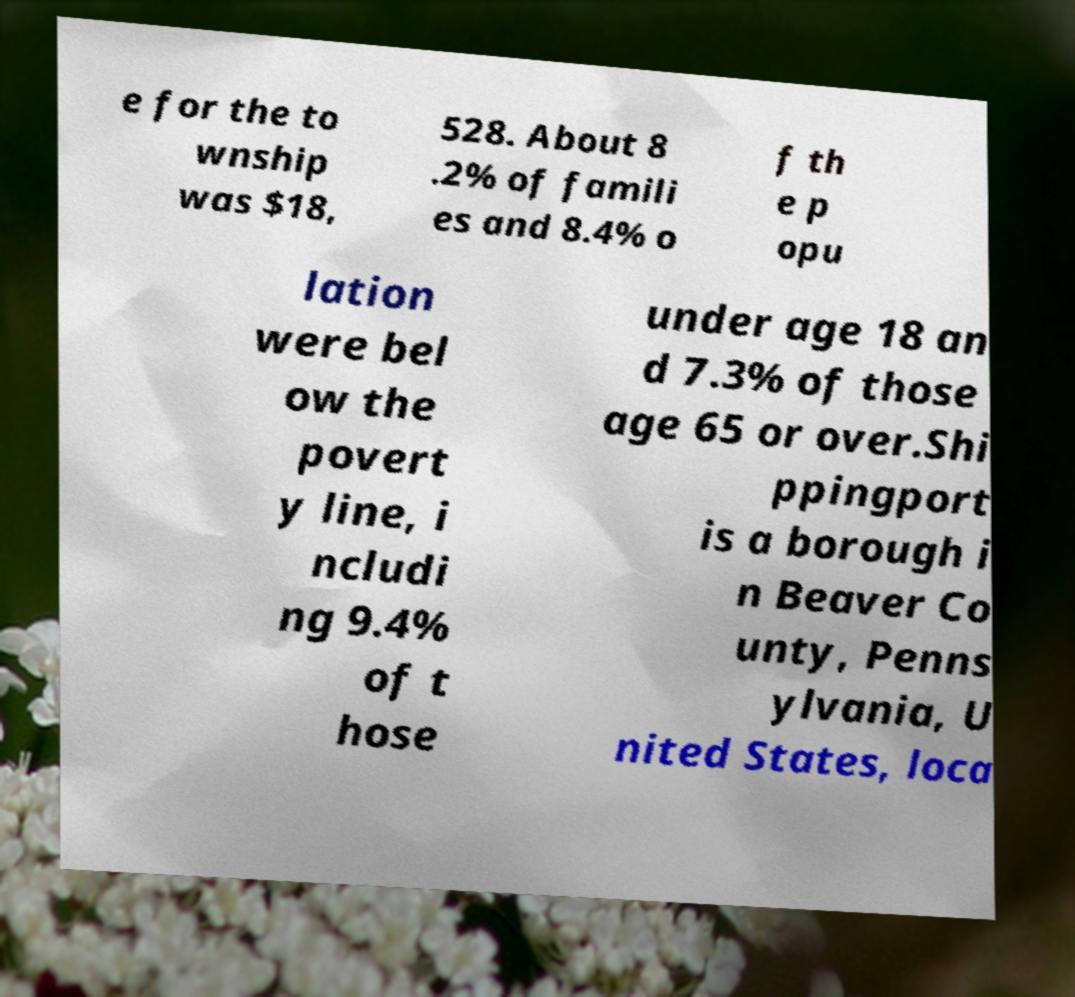For documentation purposes, I need the text within this image transcribed. Could you provide that? e for the to wnship was $18, 528. About 8 .2% of famili es and 8.4% o f th e p opu lation were bel ow the povert y line, i ncludi ng 9.4% of t hose under age 18 an d 7.3% of those age 65 or over.Shi ppingport is a borough i n Beaver Co unty, Penns ylvania, U nited States, loca 